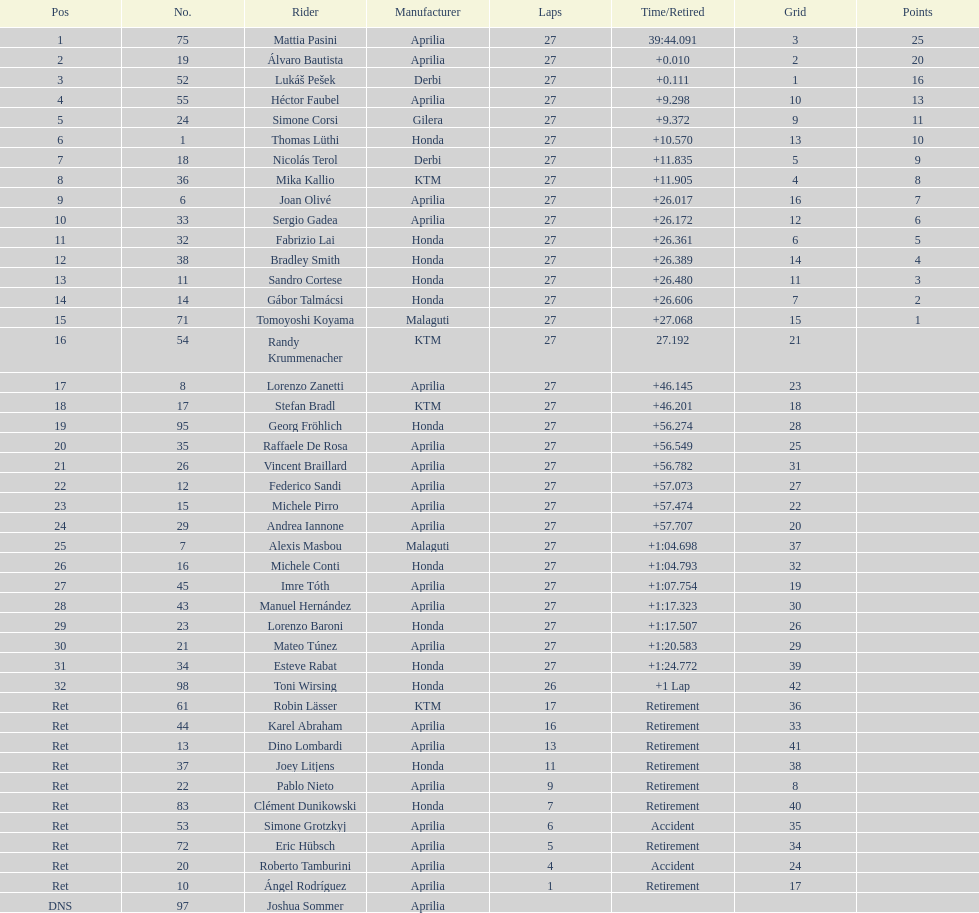Which rider secured first place with 25 points? Mattia Pasini. 